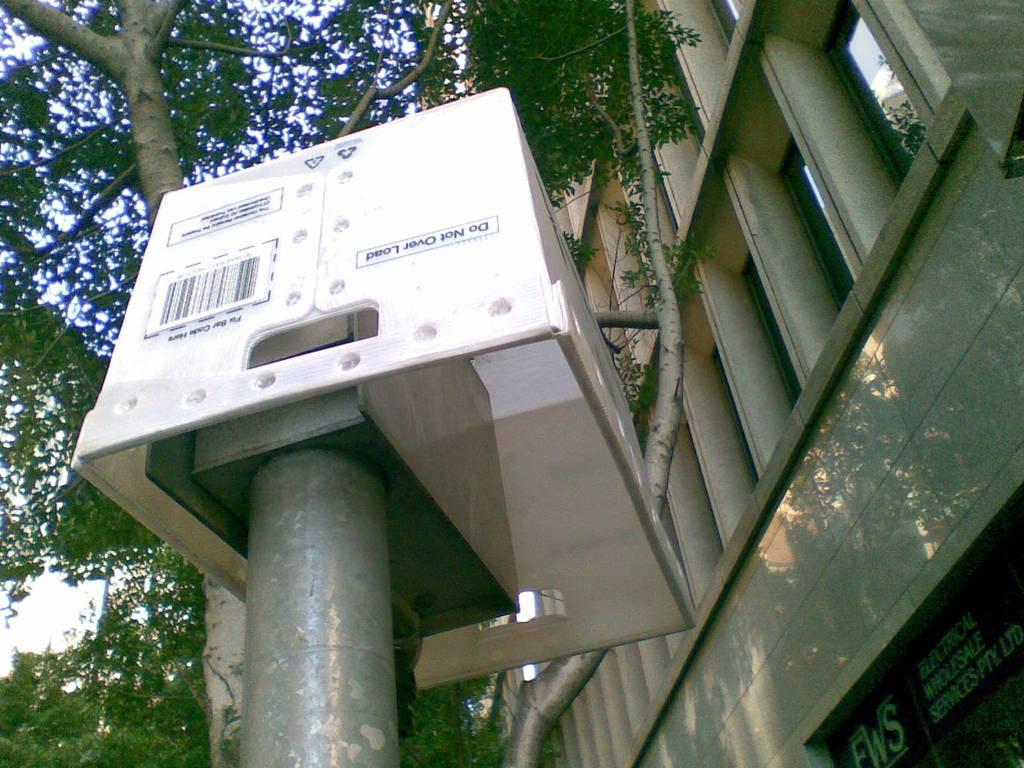Please provide a concise description of this image. There is a pole with a white color board. On that something is written. In the back there are trees. On the right side there is a building with windows. Also there is a board with something written on that. 